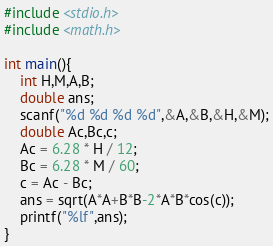<code> <loc_0><loc_0><loc_500><loc_500><_C_>#include <stdio.h>
#include <math.h>

int main(){
	int H,M,A,B;
	double ans;
	scanf("%d %d %d %d",&A,&B,&H,&M);
	double Ac,Bc,c;
	Ac = 6.28 * H / 12;
	Bc = 6.28 * M / 60;
	c = Ac - Bc;
	ans = sqrt(A*A+B*B-2*A*B*cos(c));
	printf("%lf",ans);
}
</code> 